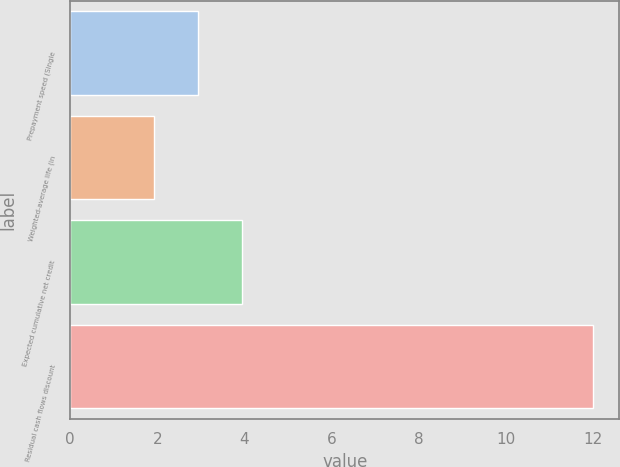Convert chart to OTSL. <chart><loc_0><loc_0><loc_500><loc_500><bar_chart><fcel>Prepayment speed (Single<fcel>Weighted-average life (in<fcel>Expected cumulative net credit<fcel>Residual cash flows discount<nl><fcel>2.94<fcel>1.93<fcel>3.95<fcel>12<nl></chart> 